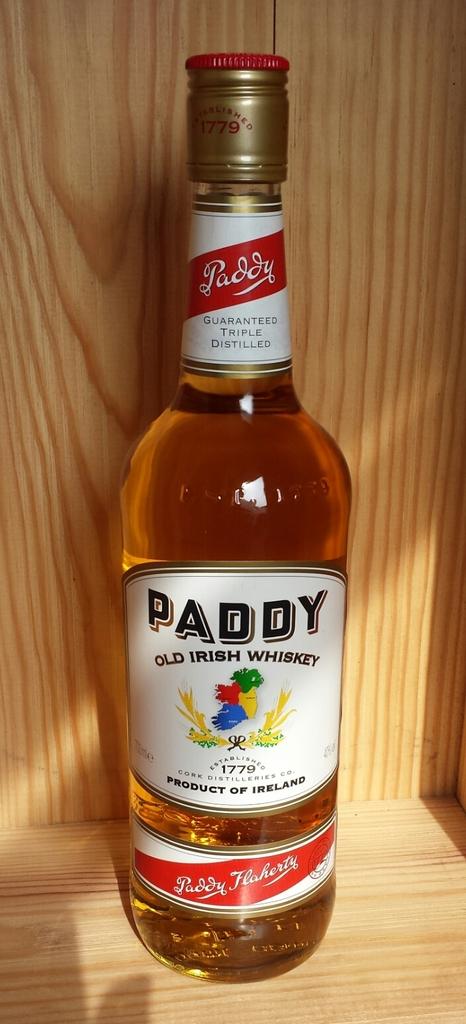What type of whiskey is in the bottle?
Provide a short and direct response. Old irish. 